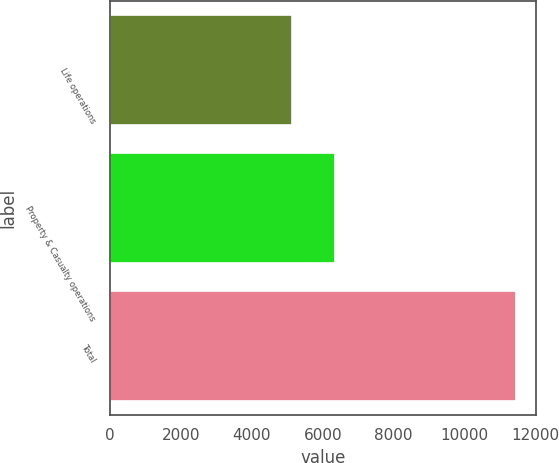<chart> <loc_0><loc_0><loc_500><loc_500><bar_chart><fcel>Life operations<fcel>Property & Casualty operations<fcel>Total<nl><fcel>5119<fcel>6337<fcel>11456<nl></chart> 